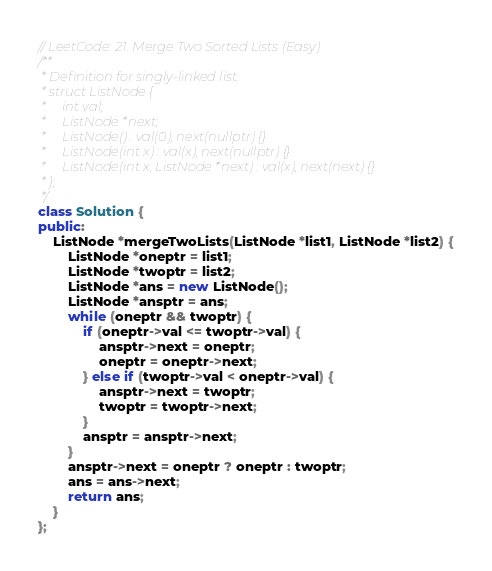<code> <loc_0><loc_0><loc_500><loc_500><_C++_>// LeetCode: 21. Merge Two Sorted Lists (Easy)
/**
 * Definition for singly-linked list.
 * struct ListNode {
 *     int val;
 *     ListNode *next;
 *     ListNode() : val(0), next(nullptr) {}
 *     ListNode(int x) : val(x), next(nullptr) {}
 *     ListNode(int x, ListNode *next) : val(x), next(next) {}
 * };
 */
class Solution {
public:
    ListNode *mergeTwoLists(ListNode *list1, ListNode *list2) {
        ListNode *oneptr = list1;
        ListNode *twoptr = list2;
        ListNode *ans = new ListNode();
        ListNode *ansptr = ans;
        while (oneptr && twoptr) {
            if (oneptr->val <= twoptr->val) {
                ansptr->next = oneptr;
                oneptr = oneptr->next;
            } else if (twoptr->val < oneptr->val) {
                ansptr->next = twoptr;
                twoptr = twoptr->next;
            }
            ansptr = ansptr->next;
        }
        ansptr->next = oneptr ? oneptr : twoptr;
        ans = ans->next;
        return ans;
    }
};</code> 